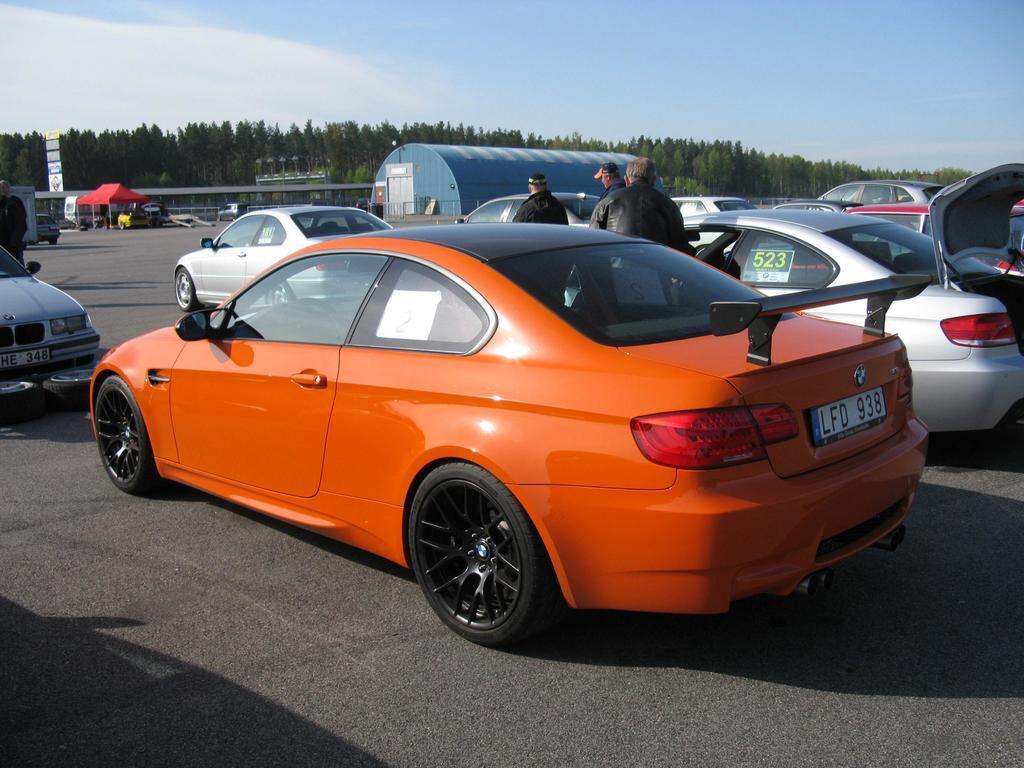Could you give a brief overview of what you see in this image? In this image in the foreground there are some cars, and in the center there are some people who are standing. At the bottom there is a road, in the background there are some trees and buildings. On the top of the image there is sky and on the left side there are some hoardings and boards. 